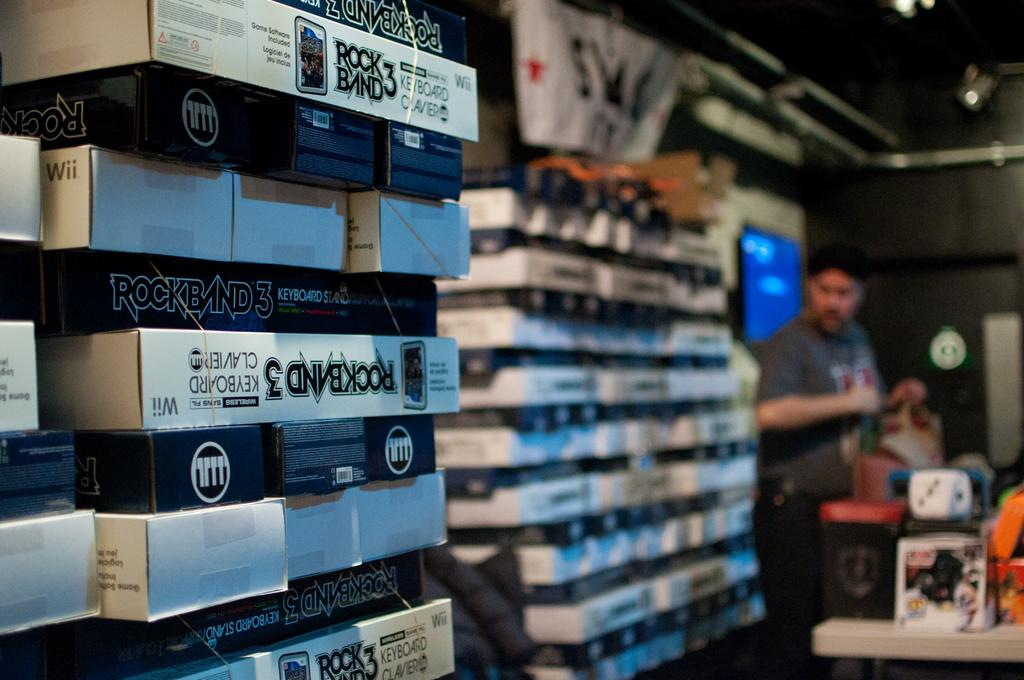<image>
Provide a brief description of the given image. A stack of merchandise for the video game Rock Band 3 